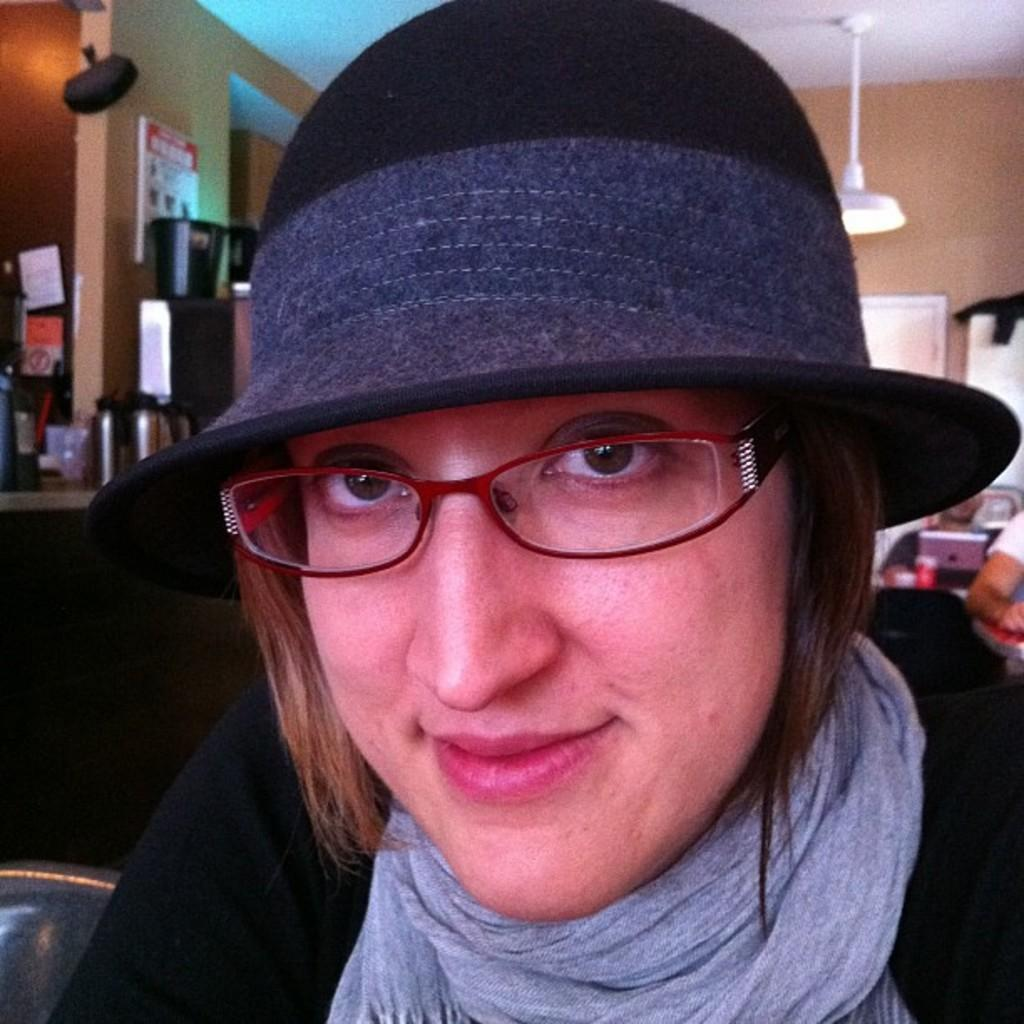What is the woman wearing on her face in the image? The woman is wearing spectacles in the image. What is the woman wearing on her head in the image? The woman is wearing a cap in the image. What is the woman wearing around her neck in the image? The woman is wearing a scarf in the image. Can you describe the background of the image? In the background of the image, there are people, a laptop, a cup, a light attached to the ceiling, boards on the walls, bottles, and other things. What type of grass is growing on the woman's head in the image? There is no grass present in the image, and the woman is wearing a cap, not grass. How does the motion of the laptop affect the image? The laptop is not in motion in the image; it is stationary on a surface. 